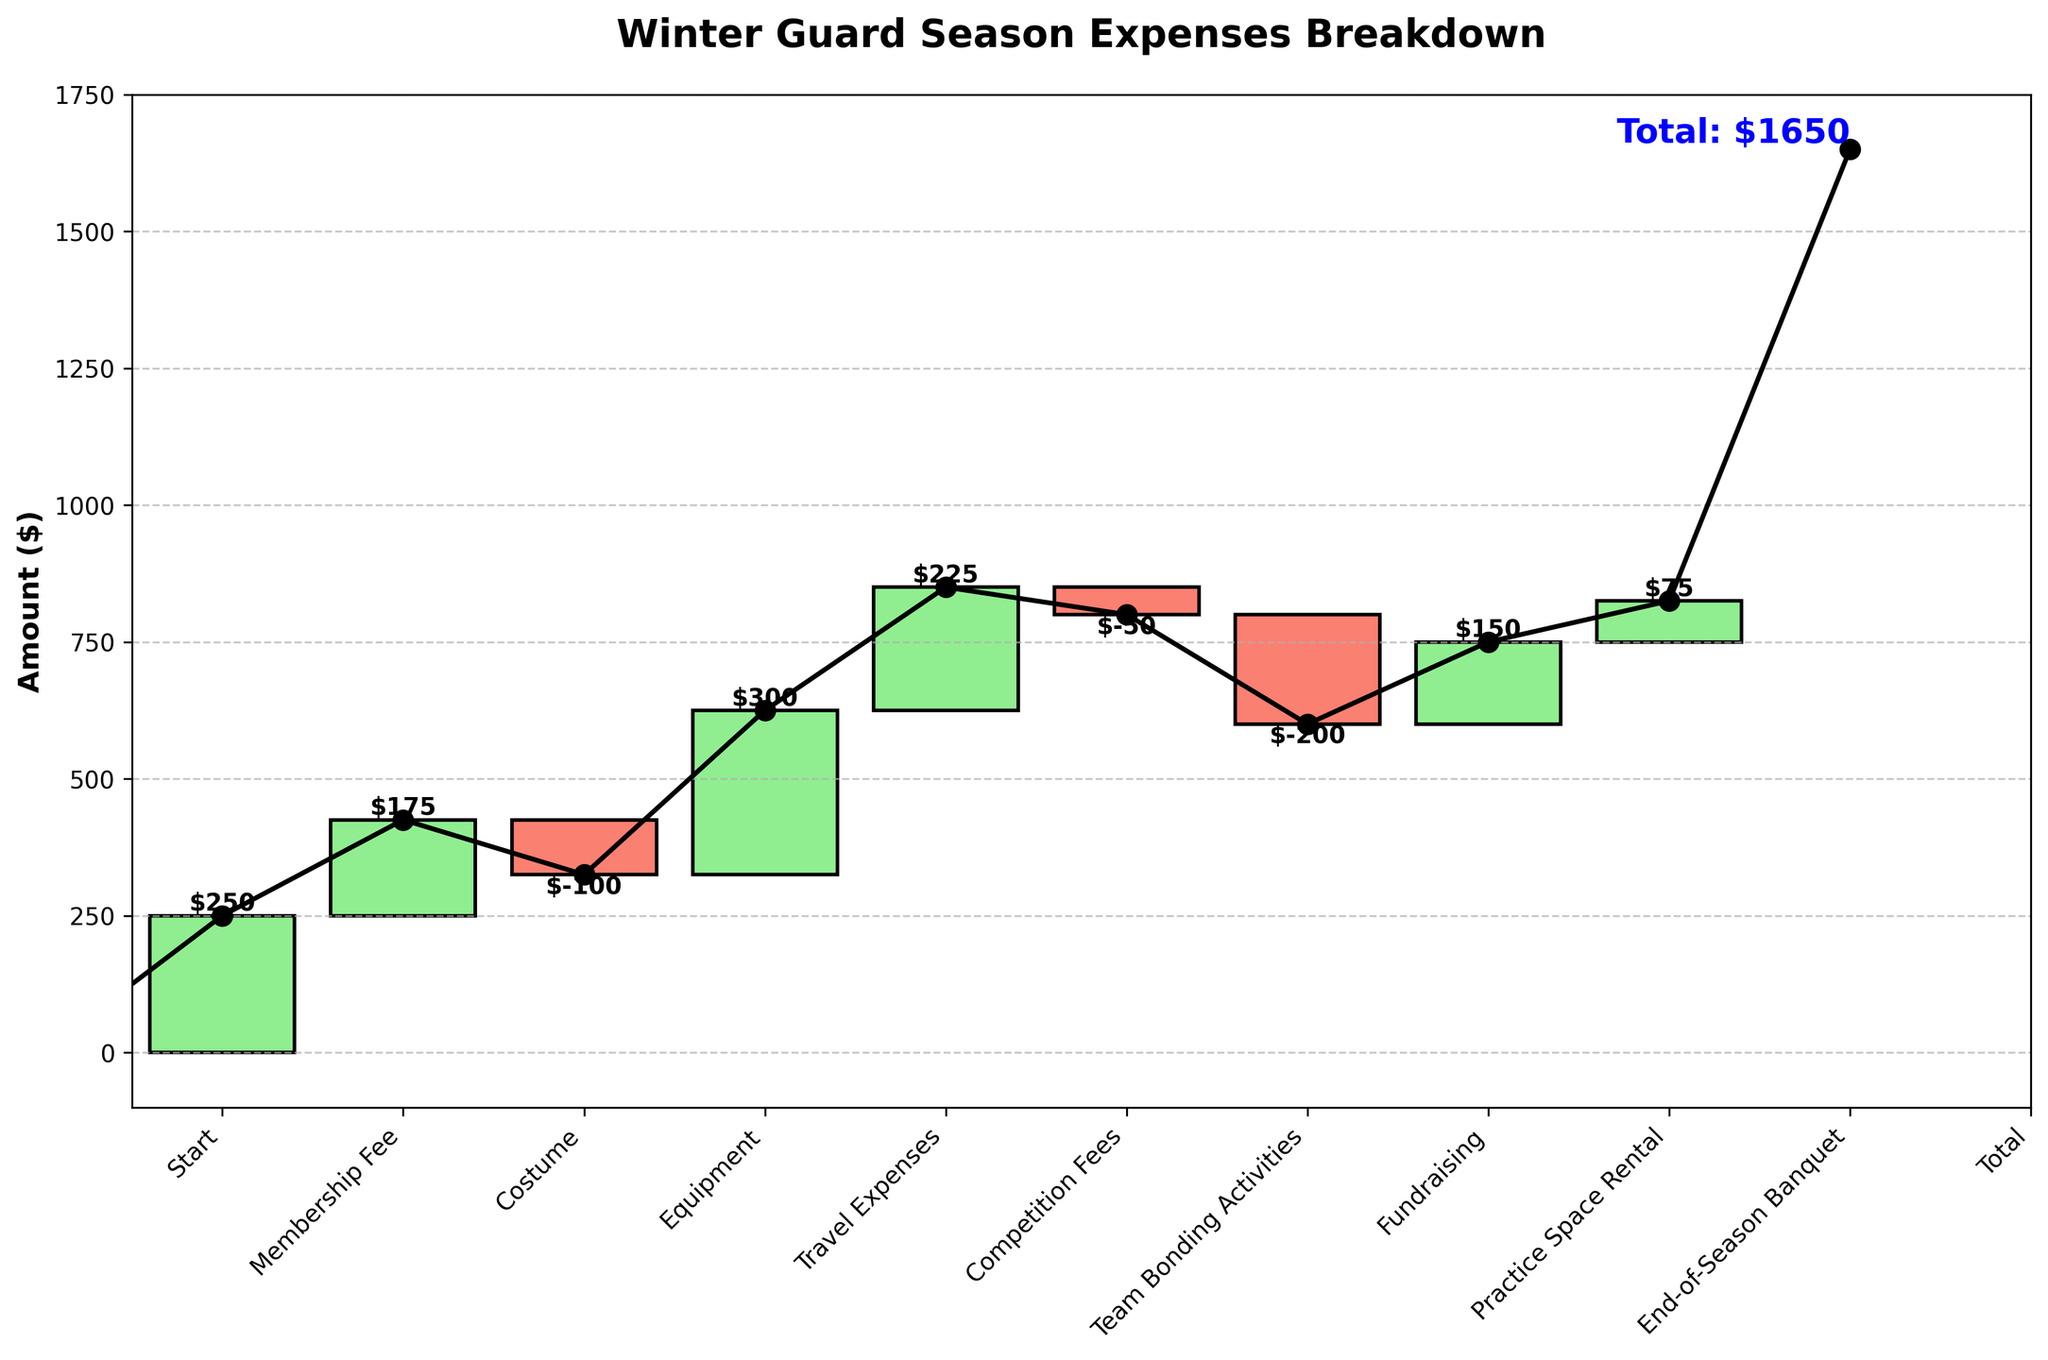What is the title of the plot? Look at the top of the plot for the large, bold text. It usually summarizes the content.
Answer: Winter Guard Season Expenses Breakdown What is the total amount of expenses at the end of the season? Check the annotation towards the end of the cumulative line or the specified position on the x-axis labeled 'Total'.
Answer: $825 Which category has the highest single expense? Identify the tallest upward bar which indicates the highest positive value.
Answer: Travel Expenses Which two categories had a negative impact, and what are their amounts? Identify the bars colored differently indicating a decrease; these bars are labeled with their respective values.
Answer: Equipment: $-100, Team Bonding Activities: $-50 What is the total contribution from positive categories (excluding the start and total)? Sum all the positive values appearing in the plot excluding the 'Start' and 'Total' categories.
Answer: $250 + $175 + $300 + $225 + $150 + $75 = $1175 How much did the team spend on 'Practice Space Rental'? Refer to the label on the relevant bar.
Answer: $150 What is the net change between 'Costume' and 'Equipment'? Subtract the amount for 'Equipment' from the amount for 'Costume'.
Answer: $175 - $100 = $75 What's the average amount for all positive categories? Sum all the positive amounts and divide by the number of positive categories.
Answer: sum = $250 + $175 + $300 + $225 + $150 + $75, count = 6, average = $1175 / 6 = $195.83 Does 'Fundraising' increase or decrease the total expenses? Refer to the label on the 'Fundraising' bar, noting if it contributes positively or negatively.
Answer: Decrease What is the difference in expense between 'Competition Fees' and 'Membership Fee'? Subtract the amount for 'Membership Fee' from 'Competition Fees'.
Answer: $225 - $250 = -$25 